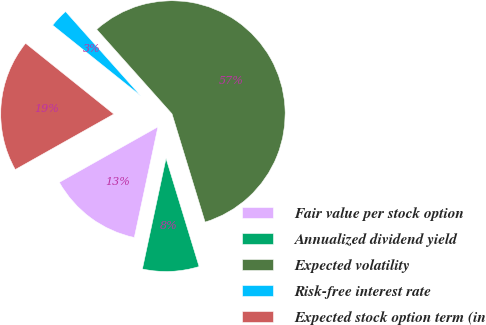Convert chart to OTSL. <chart><loc_0><loc_0><loc_500><loc_500><pie_chart><fcel>Fair value per stock option<fcel>Annualized dividend yield<fcel>Expected volatility<fcel>Risk-free interest rate<fcel>Expected stock option term (in<nl><fcel>13.49%<fcel>8.07%<fcel>56.87%<fcel>2.65%<fcel>18.92%<nl></chart> 